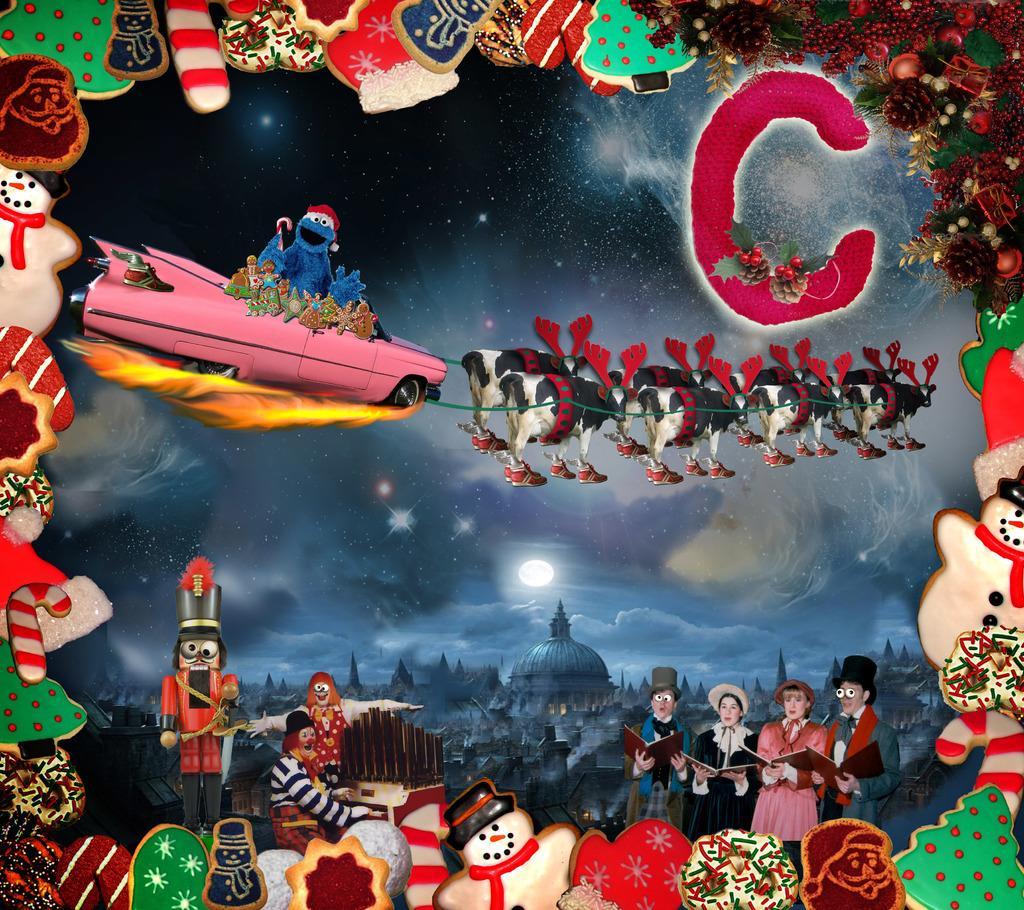Can you describe this image briefly? In the picture I can see a car and cows in the middle of the image. I can see a toy in the car. I can see four persons on the bottom right side and they are holding the book in their hands. I can see a man on bottom left side and he is playing the piano. In the background, I can see the dome construction. I can see a moon and stars in the sky. 